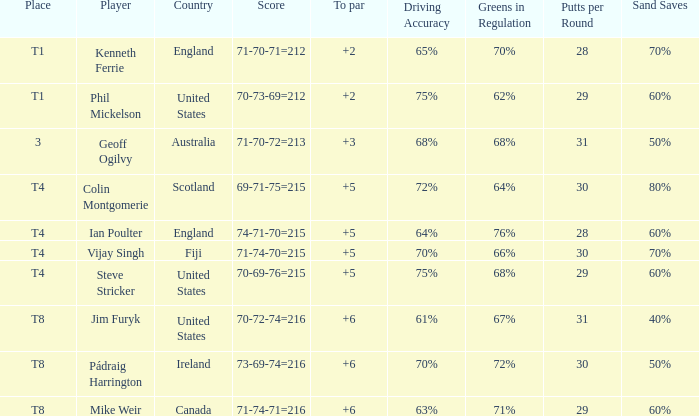Who had a score of 70-73-69=212? Phil Mickelson. 